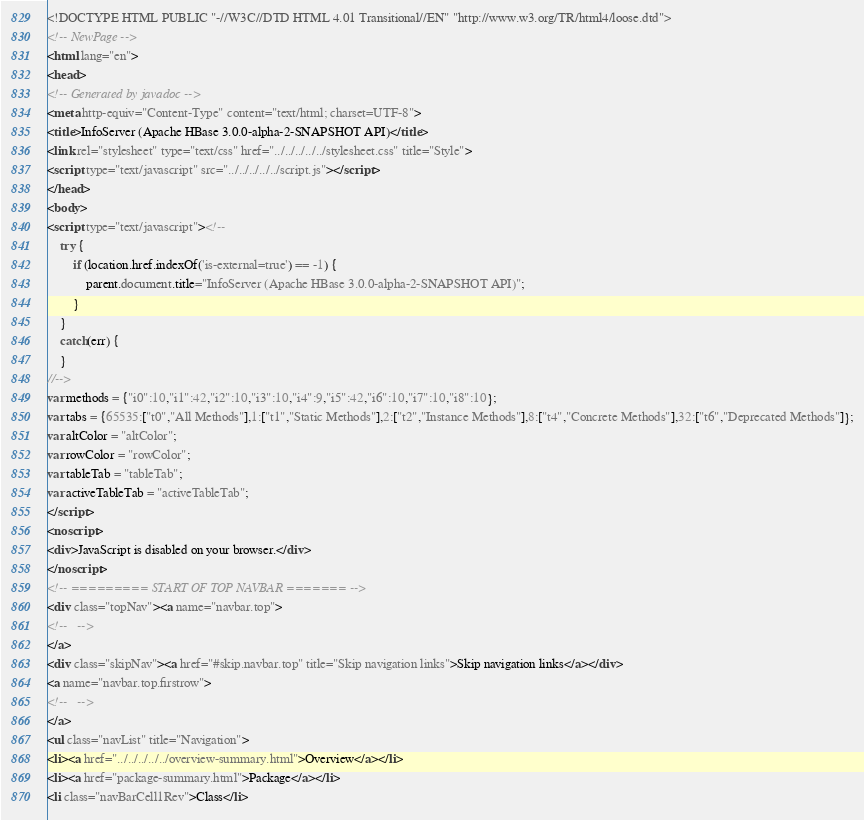<code> <loc_0><loc_0><loc_500><loc_500><_HTML_><!DOCTYPE HTML PUBLIC "-//W3C//DTD HTML 4.01 Transitional//EN" "http://www.w3.org/TR/html4/loose.dtd">
<!-- NewPage -->
<html lang="en">
<head>
<!-- Generated by javadoc -->
<meta http-equiv="Content-Type" content="text/html; charset=UTF-8">
<title>InfoServer (Apache HBase 3.0.0-alpha-2-SNAPSHOT API)</title>
<link rel="stylesheet" type="text/css" href="../../../../../stylesheet.css" title="Style">
<script type="text/javascript" src="../../../../../script.js"></script>
</head>
<body>
<script type="text/javascript"><!--
    try {
        if (location.href.indexOf('is-external=true') == -1) {
            parent.document.title="InfoServer (Apache HBase 3.0.0-alpha-2-SNAPSHOT API)";
        }
    }
    catch(err) {
    }
//-->
var methods = {"i0":10,"i1":42,"i2":10,"i3":10,"i4":9,"i5":42,"i6":10,"i7":10,"i8":10};
var tabs = {65535:["t0","All Methods"],1:["t1","Static Methods"],2:["t2","Instance Methods"],8:["t4","Concrete Methods"],32:["t6","Deprecated Methods"]};
var altColor = "altColor";
var rowColor = "rowColor";
var tableTab = "tableTab";
var activeTableTab = "activeTableTab";
</script>
<noscript>
<div>JavaScript is disabled on your browser.</div>
</noscript>
<!-- ========= START OF TOP NAVBAR ======= -->
<div class="topNav"><a name="navbar.top">
<!--   -->
</a>
<div class="skipNav"><a href="#skip.navbar.top" title="Skip navigation links">Skip navigation links</a></div>
<a name="navbar.top.firstrow">
<!--   -->
</a>
<ul class="navList" title="Navigation">
<li><a href="../../../../../overview-summary.html">Overview</a></li>
<li><a href="package-summary.html">Package</a></li>
<li class="navBarCell1Rev">Class</li></code> 